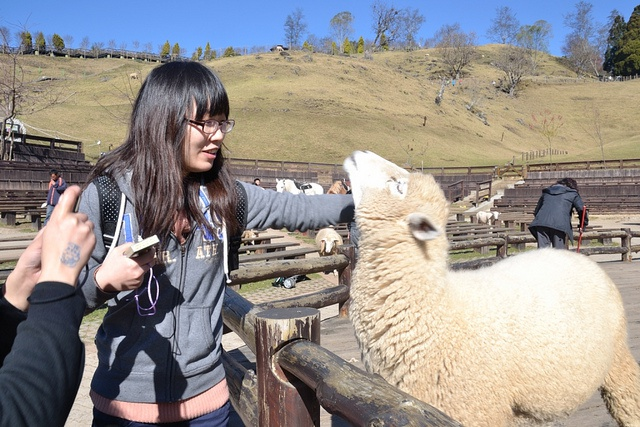Describe the objects in this image and their specific colors. I can see sheep in gray, ivory, tan, and darkgray tones, people in gray, black, and darkgray tones, people in gray, black, lightgray, and pink tones, bench in gray and darkgray tones, and backpack in gray, black, and darkgray tones in this image. 